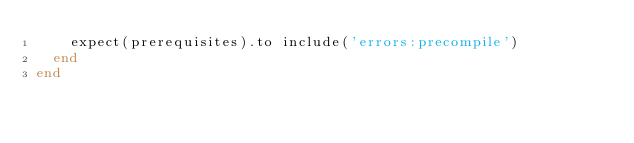Convert code to text. <code><loc_0><loc_0><loc_500><loc_500><_Ruby_>    expect(prerequisites).to include('errors:precompile')
  end
end
</code> 